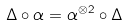<formula> <loc_0><loc_0><loc_500><loc_500>\Delta \circ \alpha = \alpha ^ { \otimes 2 } \circ \Delta</formula> 